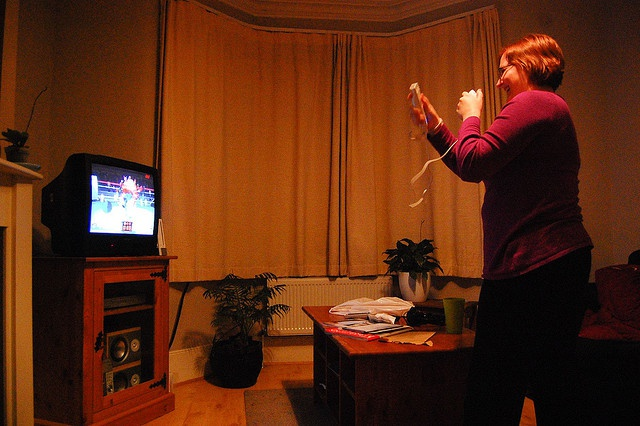Describe the objects in this image and their specific colors. I can see people in black, brown, maroon, and red tones, dining table in black, brown, and maroon tones, tv in black, white, lightblue, and navy tones, couch in black, maroon, and brown tones, and potted plant in black, maroon, and brown tones in this image. 